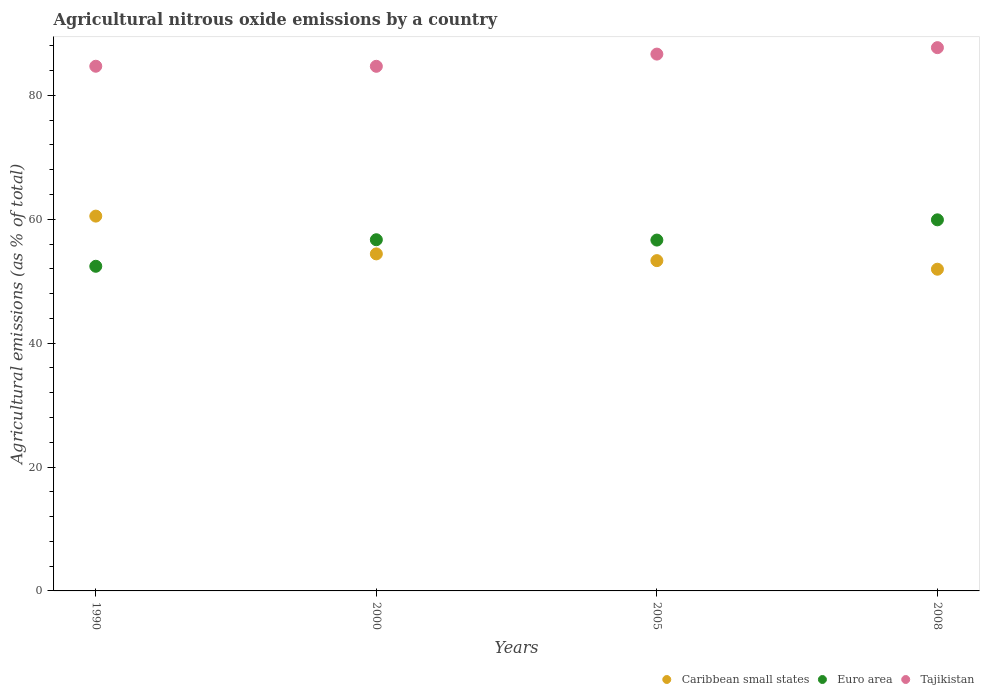How many different coloured dotlines are there?
Provide a short and direct response. 3. What is the amount of agricultural nitrous oxide emitted in Euro area in 2008?
Offer a terse response. 59.91. Across all years, what is the maximum amount of agricultural nitrous oxide emitted in Caribbean small states?
Ensure brevity in your answer.  60.51. Across all years, what is the minimum amount of agricultural nitrous oxide emitted in Euro area?
Provide a short and direct response. 52.41. In which year was the amount of agricultural nitrous oxide emitted in Caribbean small states minimum?
Offer a terse response. 2008. What is the total amount of agricultural nitrous oxide emitted in Euro area in the graph?
Provide a short and direct response. 225.64. What is the difference between the amount of agricultural nitrous oxide emitted in Euro area in 1990 and that in 2000?
Provide a succinct answer. -4.28. What is the difference between the amount of agricultural nitrous oxide emitted in Euro area in 2000 and the amount of agricultural nitrous oxide emitted in Tajikistan in 1990?
Your answer should be compact. -28.01. What is the average amount of agricultural nitrous oxide emitted in Tajikistan per year?
Provide a short and direct response. 85.94. In the year 2000, what is the difference between the amount of agricultural nitrous oxide emitted in Euro area and amount of agricultural nitrous oxide emitted in Caribbean small states?
Your answer should be compact. 2.28. What is the ratio of the amount of agricultural nitrous oxide emitted in Caribbean small states in 1990 to that in 2008?
Provide a succinct answer. 1.17. Is the amount of agricultural nitrous oxide emitted in Euro area in 2000 less than that in 2008?
Keep it short and to the point. Yes. Is the difference between the amount of agricultural nitrous oxide emitted in Euro area in 1990 and 2000 greater than the difference between the amount of agricultural nitrous oxide emitted in Caribbean small states in 1990 and 2000?
Ensure brevity in your answer.  No. What is the difference between the highest and the second highest amount of agricultural nitrous oxide emitted in Caribbean small states?
Your answer should be compact. 6.1. What is the difference between the highest and the lowest amount of agricultural nitrous oxide emitted in Caribbean small states?
Ensure brevity in your answer.  8.57. Is it the case that in every year, the sum of the amount of agricultural nitrous oxide emitted in Euro area and amount of agricultural nitrous oxide emitted in Caribbean small states  is greater than the amount of agricultural nitrous oxide emitted in Tajikistan?
Ensure brevity in your answer.  Yes. Does the amount of agricultural nitrous oxide emitted in Tajikistan monotonically increase over the years?
Give a very brief answer. No. Is the amount of agricultural nitrous oxide emitted in Tajikistan strictly greater than the amount of agricultural nitrous oxide emitted in Euro area over the years?
Keep it short and to the point. Yes. What is the difference between two consecutive major ticks on the Y-axis?
Your answer should be compact. 20. Does the graph contain grids?
Your response must be concise. No. How are the legend labels stacked?
Keep it short and to the point. Horizontal. What is the title of the graph?
Offer a very short reply. Agricultural nitrous oxide emissions by a country. Does "Bhutan" appear as one of the legend labels in the graph?
Keep it short and to the point. No. What is the label or title of the Y-axis?
Provide a succinct answer. Agricultural emissions (as % of total). What is the Agricultural emissions (as % of total) of Caribbean small states in 1990?
Your response must be concise. 60.51. What is the Agricultural emissions (as % of total) of Euro area in 1990?
Your answer should be very brief. 52.41. What is the Agricultural emissions (as % of total) of Tajikistan in 1990?
Offer a very short reply. 84.7. What is the Agricultural emissions (as % of total) of Caribbean small states in 2000?
Provide a short and direct response. 54.41. What is the Agricultural emissions (as % of total) in Euro area in 2000?
Provide a short and direct response. 56.69. What is the Agricultural emissions (as % of total) in Tajikistan in 2000?
Provide a succinct answer. 84.69. What is the Agricultural emissions (as % of total) of Caribbean small states in 2005?
Provide a succinct answer. 53.32. What is the Agricultural emissions (as % of total) in Euro area in 2005?
Your answer should be compact. 56.64. What is the Agricultural emissions (as % of total) of Tajikistan in 2005?
Offer a very short reply. 86.66. What is the Agricultural emissions (as % of total) in Caribbean small states in 2008?
Provide a succinct answer. 51.93. What is the Agricultural emissions (as % of total) in Euro area in 2008?
Give a very brief answer. 59.91. What is the Agricultural emissions (as % of total) of Tajikistan in 2008?
Make the answer very short. 87.7. Across all years, what is the maximum Agricultural emissions (as % of total) of Caribbean small states?
Your answer should be compact. 60.51. Across all years, what is the maximum Agricultural emissions (as % of total) of Euro area?
Your answer should be very brief. 59.91. Across all years, what is the maximum Agricultural emissions (as % of total) of Tajikistan?
Your answer should be very brief. 87.7. Across all years, what is the minimum Agricultural emissions (as % of total) of Caribbean small states?
Your answer should be compact. 51.93. Across all years, what is the minimum Agricultural emissions (as % of total) in Euro area?
Keep it short and to the point. 52.41. Across all years, what is the minimum Agricultural emissions (as % of total) of Tajikistan?
Offer a very short reply. 84.69. What is the total Agricultural emissions (as % of total) in Caribbean small states in the graph?
Make the answer very short. 220.17. What is the total Agricultural emissions (as % of total) of Euro area in the graph?
Your answer should be very brief. 225.64. What is the total Agricultural emissions (as % of total) of Tajikistan in the graph?
Make the answer very short. 343.75. What is the difference between the Agricultural emissions (as % of total) of Caribbean small states in 1990 and that in 2000?
Give a very brief answer. 6.1. What is the difference between the Agricultural emissions (as % of total) in Euro area in 1990 and that in 2000?
Provide a succinct answer. -4.28. What is the difference between the Agricultural emissions (as % of total) of Tajikistan in 1990 and that in 2000?
Ensure brevity in your answer.  0.01. What is the difference between the Agricultural emissions (as % of total) in Caribbean small states in 1990 and that in 2005?
Give a very brief answer. 7.19. What is the difference between the Agricultural emissions (as % of total) of Euro area in 1990 and that in 2005?
Provide a short and direct response. -4.23. What is the difference between the Agricultural emissions (as % of total) in Tajikistan in 1990 and that in 2005?
Provide a short and direct response. -1.96. What is the difference between the Agricultural emissions (as % of total) in Caribbean small states in 1990 and that in 2008?
Your answer should be compact. 8.57. What is the difference between the Agricultural emissions (as % of total) of Euro area in 1990 and that in 2008?
Ensure brevity in your answer.  -7.5. What is the difference between the Agricultural emissions (as % of total) in Tajikistan in 1990 and that in 2008?
Make the answer very short. -3. What is the difference between the Agricultural emissions (as % of total) of Caribbean small states in 2000 and that in 2005?
Ensure brevity in your answer.  1.09. What is the difference between the Agricultural emissions (as % of total) of Euro area in 2000 and that in 2005?
Offer a terse response. 0.05. What is the difference between the Agricultural emissions (as % of total) in Tajikistan in 2000 and that in 2005?
Your response must be concise. -1.97. What is the difference between the Agricultural emissions (as % of total) of Caribbean small states in 2000 and that in 2008?
Provide a succinct answer. 2.47. What is the difference between the Agricultural emissions (as % of total) of Euro area in 2000 and that in 2008?
Offer a very short reply. -3.21. What is the difference between the Agricultural emissions (as % of total) in Tajikistan in 2000 and that in 2008?
Make the answer very short. -3.01. What is the difference between the Agricultural emissions (as % of total) of Caribbean small states in 2005 and that in 2008?
Provide a short and direct response. 1.39. What is the difference between the Agricultural emissions (as % of total) in Euro area in 2005 and that in 2008?
Make the answer very short. -3.27. What is the difference between the Agricultural emissions (as % of total) of Tajikistan in 2005 and that in 2008?
Give a very brief answer. -1.04. What is the difference between the Agricultural emissions (as % of total) in Caribbean small states in 1990 and the Agricultural emissions (as % of total) in Euro area in 2000?
Offer a very short reply. 3.81. What is the difference between the Agricultural emissions (as % of total) of Caribbean small states in 1990 and the Agricultural emissions (as % of total) of Tajikistan in 2000?
Offer a terse response. -24.18. What is the difference between the Agricultural emissions (as % of total) in Euro area in 1990 and the Agricultural emissions (as % of total) in Tajikistan in 2000?
Your response must be concise. -32.28. What is the difference between the Agricultural emissions (as % of total) in Caribbean small states in 1990 and the Agricultural emissions (as % of total) in Euro area in 2005?
Provide a succinct answer. 3.87. What is the difference between the Agricultural emissions (as % of total) in Caribbean small states in 1990 and the Agricultural emissions (as % of total) in Tajikistan in 2005?
Ensure brevity in your answer.  -26.15. What is the difference between the Agricultural emissions (as % of total) of Euro area in 1990 and the Agricultural emissions (as % of total) of Tajikistan in 2005?
Provide a succinct answer. -34.25. What is the difference between the Agricultural emissions (as % of total) of Caribbean small states in 1990 and the Agricultural emissions (as % of total) of Euro area in 2008?
Offer a very short reply. 0.6. What is the difference between the Agricultural emissions (as % of total) in Caribbean small states in 1990 and the Agricultural emissions (as % of total) in Tajikistan in 2008?
Your answer should be compact. -27.19. What is the difference between the Agricultural emissions (as % of total) of Euro area in 1990 and the Agricultural emissions (as % of total) of Tajikistan in 2008?
Offer a terse response. -35.29. What is the difference between the Agricultural emissions (as % of total) of Caribbean small states in 2000 and the Agricultural emissions (as % of total) of Euro area in 2005?
Your response must be concise. -2.23. What is the difference between the Agricultural emissions (as % of total) in Caribbean small states in 2000 and the Agricultural emissions (as % of total) in Tajikistan in 2005?
Give a very brief answer. -32.25. What is the difference between the Agricultural emissions (as % of total) of Euro area in 2000 and the Agricultural emissions (as % of total) of Tajikistan in 2005?
Make the answer very short. -29.97. What is the difference between the Agricultural emissions (as % of total) of Caribbean small states in 2000 and the Agricultural emissions (as % of total) of Euro area in 2008?
Ensure brevity in your answer.  -5.5. What is the difference between the Agricultural emissions (as % of total) in Caribbean small states in 2000 and the Agricultural emissions (as % of total) in Tajikistan in 2008?
Offer a very short reply. -33.29. What is the difference between the Agricultural emissions (as % of total) of Euro area in 2000 and the Agricultural emissions (as % of total) of Tajikistan in 2008?
Your answer should be compact. -31.01. What is the difference between the Agricultural emissions (as % of total) in Caribbean small states in 2005 and the Agricultural emissions (as % of total) in Euro area in 2008?
Make the answer very short. -6.59. What is the difference between the Agricultural emissions (as % of total) in Caribbean small states in 2005 and the Agricultural emissions (as % of total) in Tajikistan in 2008?
Make the answer very short. -34.38. What is the difference between the Agricultural emissions (as % of total) in Euro area in 2005 and the Agricultural emissions (as % of total) in Tajikistan in 2008?
Ensure brevity in your answer.  -31.06. What is the average Agricultural emissions (as % of total) in Caribbean small states per year?
Your answer should be very brief. 55.04. What is the average Agricultural emissions (as % of total) in Euro area per year?
Keep it short and to the point. 56.41. What is the average Agricultural emissions (as % of total) of Tajikistan per year?
Your answer should be compact. 85.94. In the year 1990, what is the difference between the Agricultural emissions (as % of total) in Caribbean small states and Agricultural emissions (as % of total) in Euro area?
Give a very brief answer. 8.1. In the year 1990, what is the difference between the Agricultural emissions (as % of total) in Caribbean small states and Agricultural emissions (as % of total) in Tajikistan?
Offer a terse response. -24.19. In the year 1990, what is the difference between the Agricultural emissions (as % of total) of Euro area and Agricultural emissions (as % of total) of Tajikistan?
Ensure brevity in your answer.  -32.29. In the year 2000, what is the difference between the Agricultural emissions (as % of total) of Caribbean small states and Agricultural emissions (as % of total) of Euro area?
Provide a short and direct response. -2.28. In the year 2000, what is the difference between the Agricultural emissions (as % of total) of Caribbean small states and Agricultural emissions (as % of total) of Tajikistan?
Provide a succinct answer. -30.28. In the year 2000, what is the difference between the Agricultural emissions (as % of total) in Euro area and Agricultural emissions (as % of total) in Tajikistan?
Your answer should be compact. -28. In the year 2005, what is the difference between the Agricultural emissions (as % of total) in Caribbean small states and Agricultural emissions (as % of total) in Euro area?
Ensure brevity in your answer.  -3.32. In the year 2005, what is the difference between the Agricultural emissions (as % of total) of Caribbean small states and Agricultural emissions (as % of total) of Tajikistan?
Give a very brief answer. -33.34. In the year 2005, what is the difference between the Agricultural emissions (as % of total) in Euro area and Agricultural emissions (as % of total) in Tajikistan?
Keep it short and to the point. -30.02. In the year 2008, what is the difference between the Agricultural emissions (as % of total) of Caribbean small states and Agricultural emissions (as % of total) of Euro area?
Give a very brief answer. -7.97. In the year 2008, what is the difference between the Agricultural emissions (as % of total) in Caribbean small states and Agricultural emissions (as % of total) in Tajikistan?
Your answer should be very brief. -35.77. In the year 2008, what is the difference between the Agricultural emissions (as % of total) of Euro area and Agricultural emissions (as % of total) of Tajikistan?
Offer a terse response. -27.79. What is the ratio of the Agricultural emissions (as % of total) in Caribbean small states in 1990 to that in 2000?
Your answer should be very brief. 1.11. What is the ratio of the Agricultural emissions (as % of total) in Euro area in 1990 to that in 2000?
Give a very brief answer. 0.92. What is the ratio of the Agricultural emissions (as % of total) in Caribbean small states in 1990 to that in 2005?
Offer a very short reply. 1.13. What is the ratio of the Agricultural emissions (as % of total) of Euro area in 1990 to that in 2005?
Your response must be concise. 0.93. What is the ratio of the Agricultural emissions (as % of total) in Tajikistan in 1990 to that in 2005?
Offer a terse response. 0.98. What is the ratio of the Agricultural emissions (as % of total) in Caribbean small states in 1990 to that in 2008?
Make the answer very short. 1.17. What is the ratio of the Agricultural emissions (as % of total) in Euro area in 1990 to that in 2008?
Offer a terse response. 0.87. What is the ratio of the Agricultural emissions (as % of total) in Tajikistan in 1990 to that in 2008?
Provide a short and direct response. 0.97. What is the ratio of the Agricultural emissions (as % of total) of Caribbean small states in 2000 to that in 2005?
Your answer should be very brief. 1.02. What is the ratio of the Agricultural emissions (as % of total) in Euro area in 2000 to that in 2005?
Give a very brief answer. 1. What is the ratio of the Agricultural emissions (as % of total) of Tajikistan in 2000 to that in 2005?
Offer a terse response. 0.98. What is the ratio of the Agricultural emissions (as % of total) of Caribbean small states in 2000 to that in 2008?
Provide a short and direct response. 1.05. What is the ratio of the Agricultural emissions (as % of total) in Euro area in 2000 to that in 2008?
Provide a short and direct response. 0.95. What is the ratio of the Agricultural emissions (as % of total) in Tajikistan in 2000 to that in 2008?
Provide a succinct answer. 0.97. What is the ratio of the Agricultural emissions (as % of total) in Caribbean small states in 2005 to that in 2008?
Give a very brief answer. 1.03. What is the ratio of the Agricultural emissions (as % of total) of Euro area in 2005 to that in 2008?
Offer a terse response. 0.95. What is the ratio of the Agricultural emissions (as % of total) of Tajikistan in 2005 to that in 2008?
Your answer should be compact. 0.99. What is the difference between the highest and the second highest Agricultural emissions (as % of total) in Caribbean small states?
Ensure brevity in your answer.  6.1. What is the difference between the highest and the second highest Agricultural emissions (as % of total) of Euro area?
Provide a short and direct response. 3.21. What is the difference between the highest and the second highest Agricultural emissions (as % of total) in Tajikistan?
Your answer should be very brief. 1.04. What is the difference between the highest and the lowest Agricultural emissions (as % of total) in Caribbean small states?
Ensure brevity in your answer.  8.57. What is the difference between the highest and the lowest Agricultural emissions (as % of total) of Euro area?
Ensure brevity in your answer.  7.5. What is the difference between the highest and the lowest Agricultural emissions (as % of total) in Tajikistan?
Your response must be concise. 3.01. 